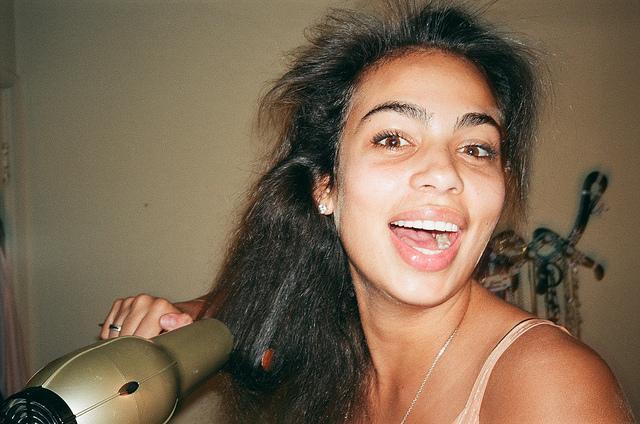How many people are in the picture?
Give a very brief answer. 1. How many orange boats are there?
Give a very brief answer. 0. 